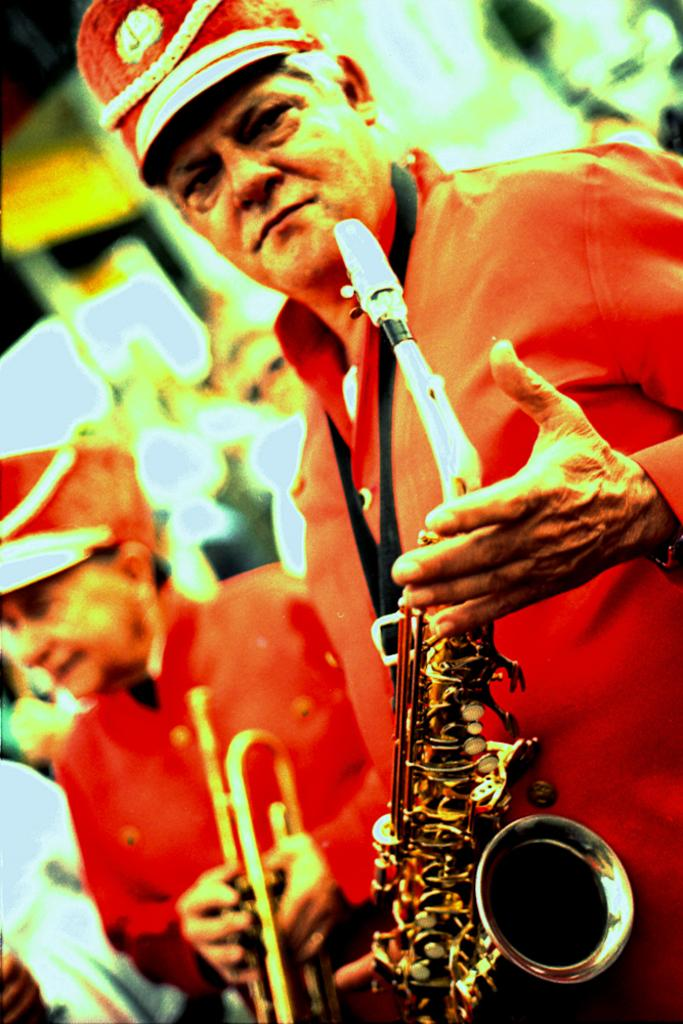What is the man in the image wearing? The man is wearing a red dress. What is the man holding in the image? The man is holding a saxophone. How many people are in the image? There are two people in the image. What is the second man holding in the image? The second man is holding a trumpet. Can you describe the background of the image? The background of the image is blurred. Can you see any mice running around near the faucet in the image? There are no mice or faucets present in the image. 